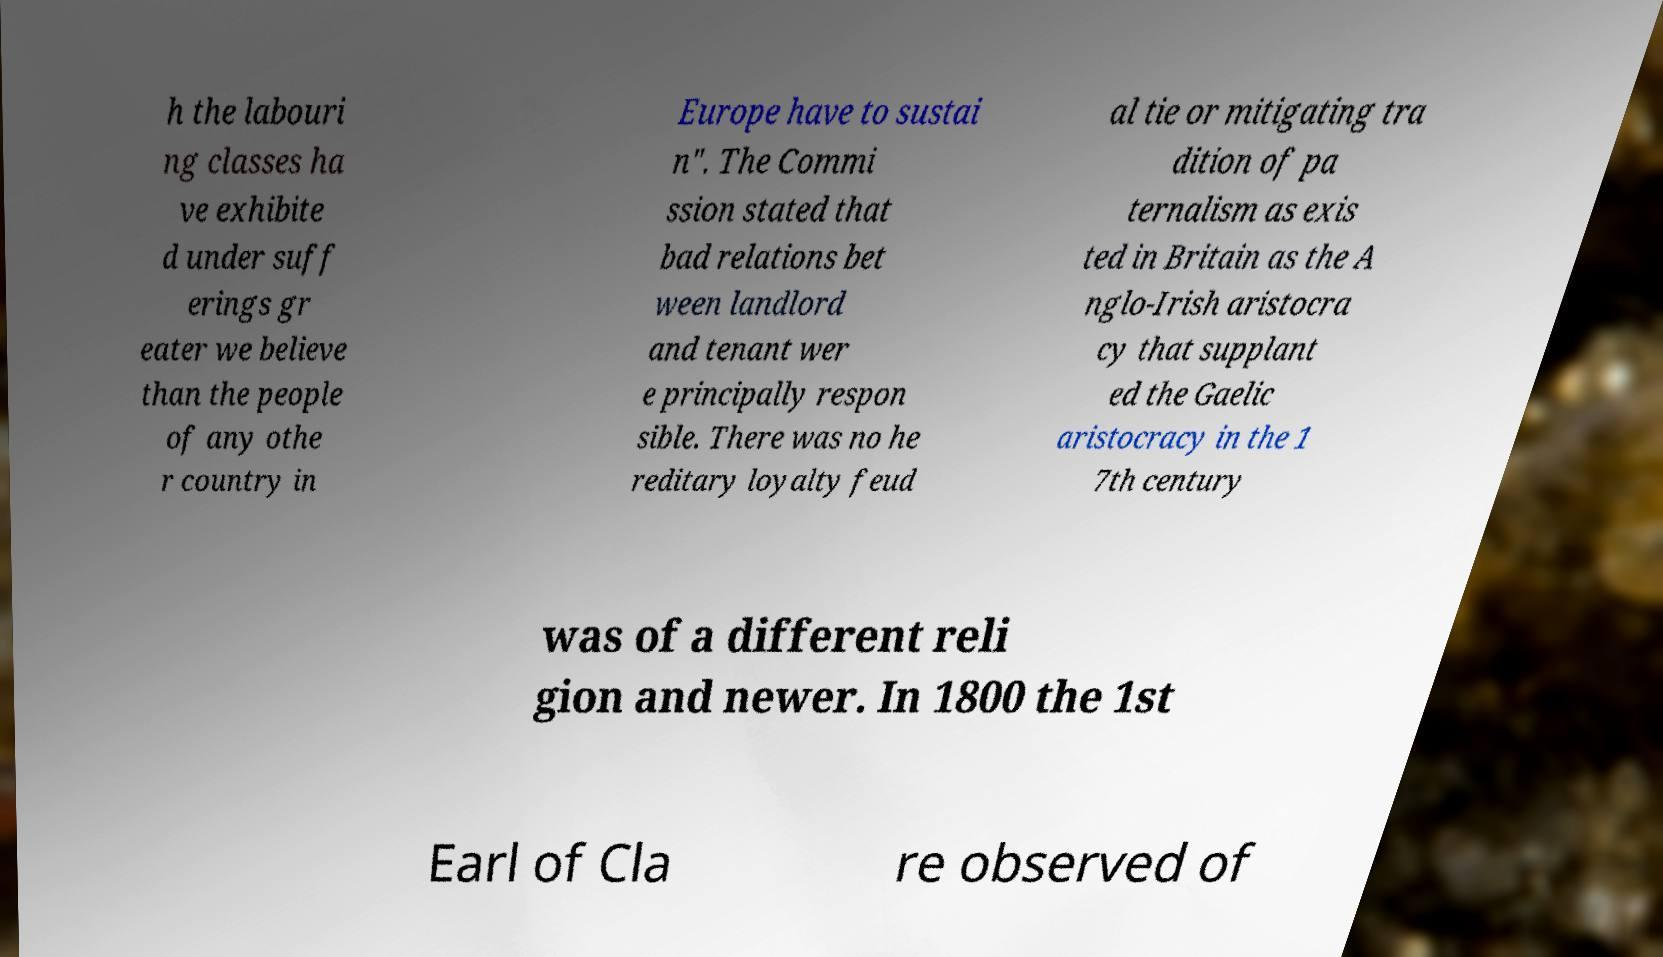Please read and relay the text visible in this image. What does it say? h the labouri ng classes ha ve exhibite d under suff erings gr eater we believe than the people of any othe r country in Europe have to sustai n". The Commi ssion stated that bad relations bet ween landlord and tenant wer e principally respon sible. There was no he reditary loyalty feud al tie or mitigating tra dition of pa ternalism as exis ted in Britain as the A nglo-Irish aristocra cy that supplant ed the Gaelic aristocracy in the 1 7th century was of a different reli gion and newer. In 1800 the 1st Earl of Cla re observed of 